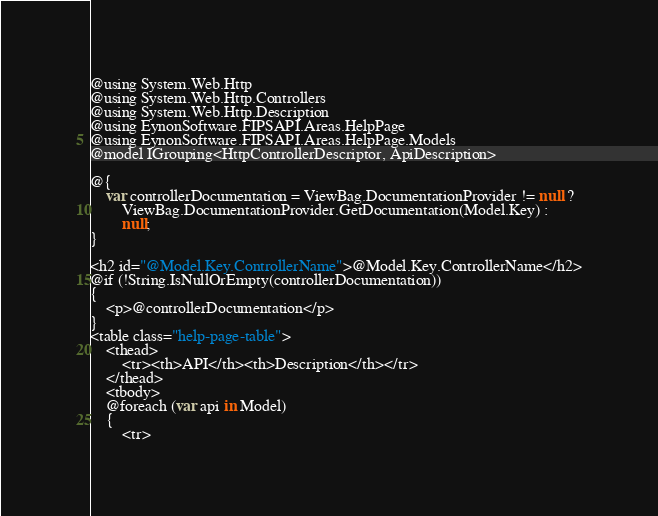Convert code to text. <code><loc_0><loc_0><loc_500><loc_500><_C#_>@using System.Web.Http
@using System.Web.Http.Controllers
@using System.Web.Http.Description
@using EynonSoftware.FIPSAPI.Areas.HelpPage
@using EynonSoftware.FIPSAPI.Areas.HelpPage.Models
@model IGrouping<HttpControllerDescriptor, ApiDescription>

@{
    var controllerDocumentation = ViewBag.DocumentationProvider != null ? 
        ViewBag.DocumentationProvider.GetDocumentation(Model.Key) : 
        null;
}

<h2 id="@Model.Key.ControllerName">@Model.Key.ControllerName</h2>
@if (!String.IsNullOrEmpty(controllerDocumentation))
{
    <p>@controllerDocumentation</p>
}
<table class="help-page-table">
    <thead>
        <tr><th>API</th><th>Description</th></tr>
    </thead>
    <tbody>
    @foreach (var api in Model)
    {
        <tr></code> 